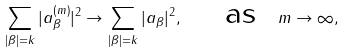Convert formula to latex. <formula><loc_0><loc_0><loc_500><loc_500>\sum _ { | \beta | = k } | a _ { \beta } ^ { ( m ) } | ^ { 2 } \to \sum _ { | \beta | = k } | a _ { \beta } | ^ { 2 } , \quad \text { as } \ m \to \infty ,</formula> 